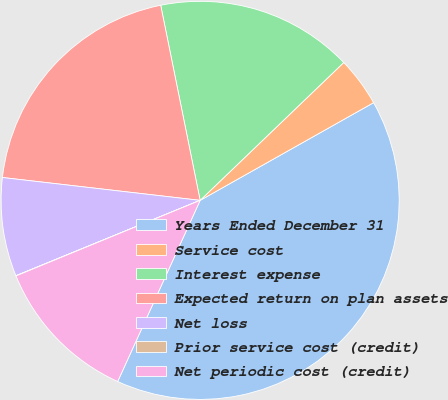Convert chart to OTSL. <chart><loc_0><loc_0><loc_500><loc_500><pie_chart><fcel>Years Ended December 31<fcel>Service cost<fcel>Interest expense<fcel>Expected return on plan assets<fcel>Net loss<fcel>Prior service cost (credit)<fcel>Net periodic cost (credit)<nl><fcel>39.96%<fcel>4.01%<fcel>16.0%<fcel>19.99%<fcel>8.01%<fcel>0.02%<fcel>12.0%<nl></chart> 